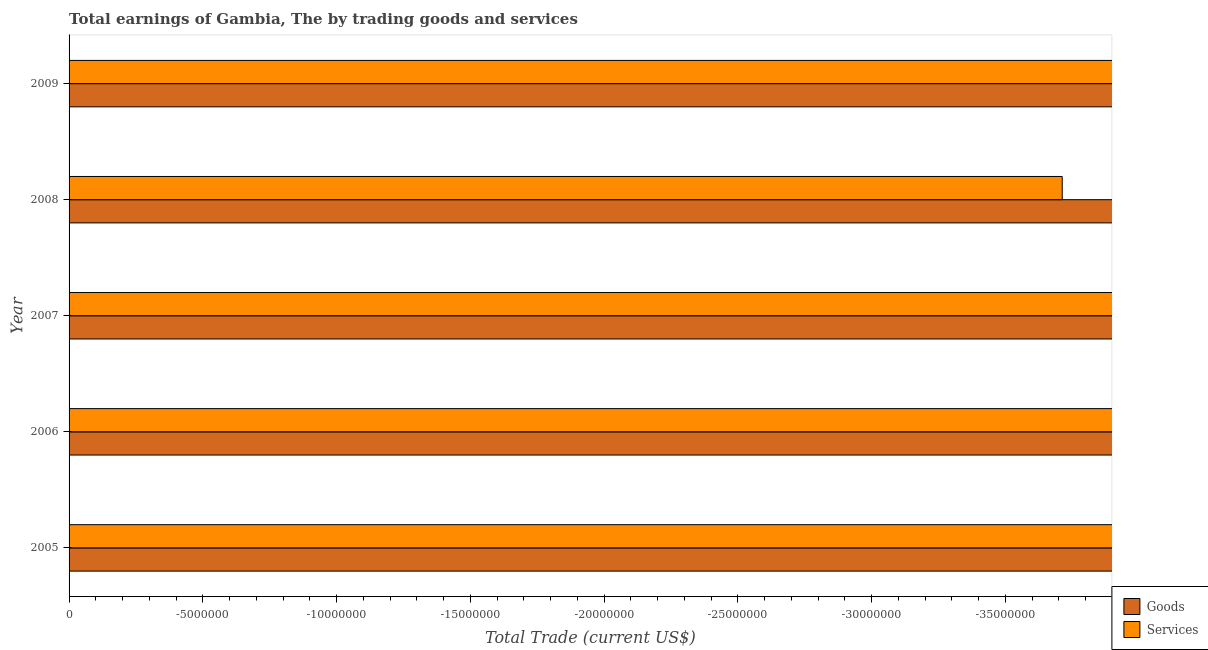How many different coloured bars are there?
Your answer should be very brief. 0. Are the number of bars per tick equal to the number of legend labels?
Ensure brevity in your answer.  No. What is the difference between the amount earned by trading services in 2005 and the amount earned by trading goods in 2008?
Provide a succinct answer. 0. What is the average amount earned by trading goods per year?
Give a very brief answer. 0. In how many years, is the amount earned by trading goods greater than -26000000 US$?
Offer a terse response. 0. Are all the bars in the graph horizontal?
Provide a succinct answer. Yes. How many years are there in the graph?
Your answer should be compact. 5. What is the difference between two consecutive major ticks on the X-axis?
Make the answer very short. 5.00e+06. Does the graph contain any zero values?
Your answer should be compact. Yes. How many legend labels are there?
Your response must be concise. 2. What is the title of the graph?
Offer a very short reply. Total earnings of Gambia, The by trading goods and services. Does "Education" appear as one of the legend labels in the graph?
Your answer should be compact. No. What is the label or title of the X-axis?
Offer a very short reply. Total Trade (current US$). What is the Total Trade (current US$) of Goods in 2005?
Provide a succinct answer. 0. What is the Total Trade (current US$) of Services in 2005?
Give a very brief answer. 0. What is the Total Trade (current US$) in Services in 2006?
Offer a terse response. 0. What is the Total Trade (current US$) of Goods in 2007?
Your answer should be very brief. 0. What is the Total Trade (current US$) in Goods in 2008?
Keep it short and to the point. 0. What is the Total Trade (current US$) in Services in 2009?
Your answer should be compact. 0. What is the total Total Trade (current US$) in Goods in the graph?
Give a very brief answer. 0. 